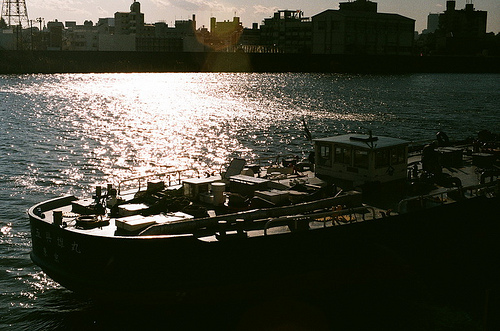Is it an outdoors scene? Yes, the scene is outdoors, showing a body of water with boats under a bright sky. 